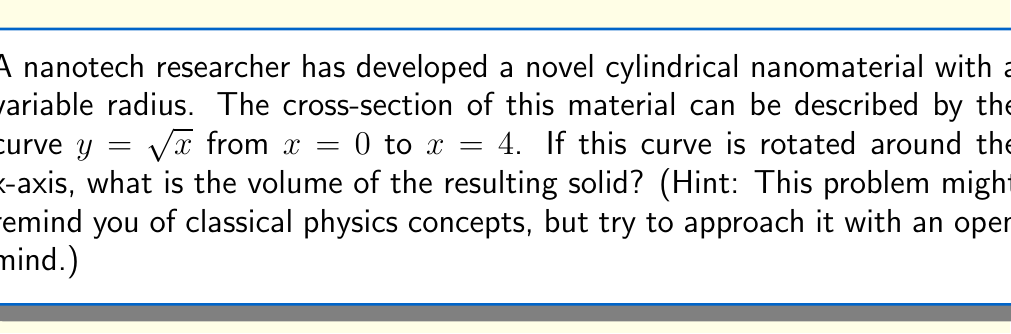Teach me how to tackle this problem. To find the volume of a solid formed by rotating a curve around the x-axis, we use the washer method from calculus. The steps are as follows:

1) The volume is given by the integral:

   $$V = \pi \int_a^b [f(x)]^2 dx$$

   where $f(x)$ is the function being rotated, and $a$ and $b$ are the limits of rotation.

2) In this case, $f(x) = \sqrt{x}$, $a = 0$, and $b = 4$. Substituting these into our formula:

   $$V = \pi \int_0^4 (\sqrt{x})^2 dx$$

3) Simplify the integrand:

   $$V = \pi \int_0^4 x dx$$

4) Integrate:

   $$V = \pi [\frac{1}{2}x^2]_0^4$$

5) Evaluate the definite integral:

   $$V = \pi [\frac{1}{2}(4^2) - \frac{1}{2}(0^2)]$$
   $$V = \pi [8 - 0]$$
   $$V = 8\pi$$

Therefore, the volume of the solid is $8\pi$ cubic units.
Answer: $8\pi$ cubic units 